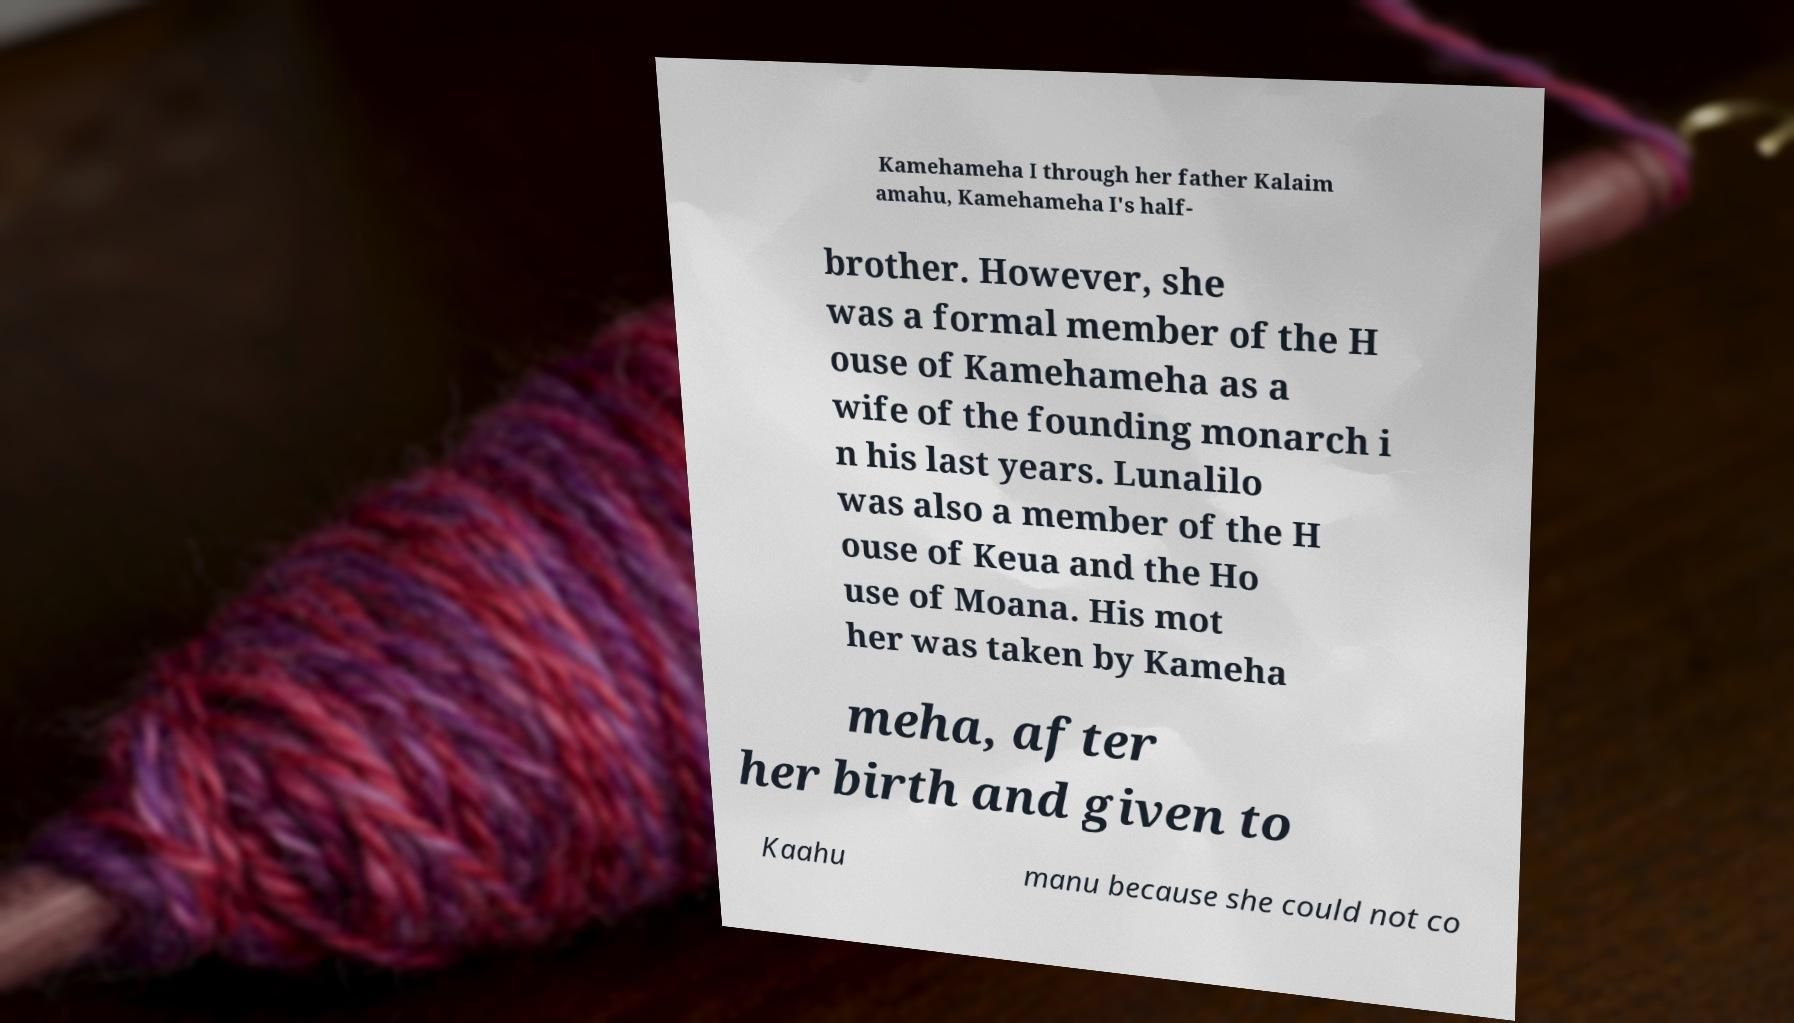Can you accurately transcribe the text from the provided image for me? Kamehameha I through her father Kalaim amahu, Kamehameha I's half- brother. However, she was a formal member of the H ouse of Kamehameha as a wife of the founding monarch i n his last years. Lunalilo was also a member of the H ouse of Keua and the Ho use of Moana. His mot her was taken by Kameha meha, after her birth and given to Kaahu manu because she could not co 